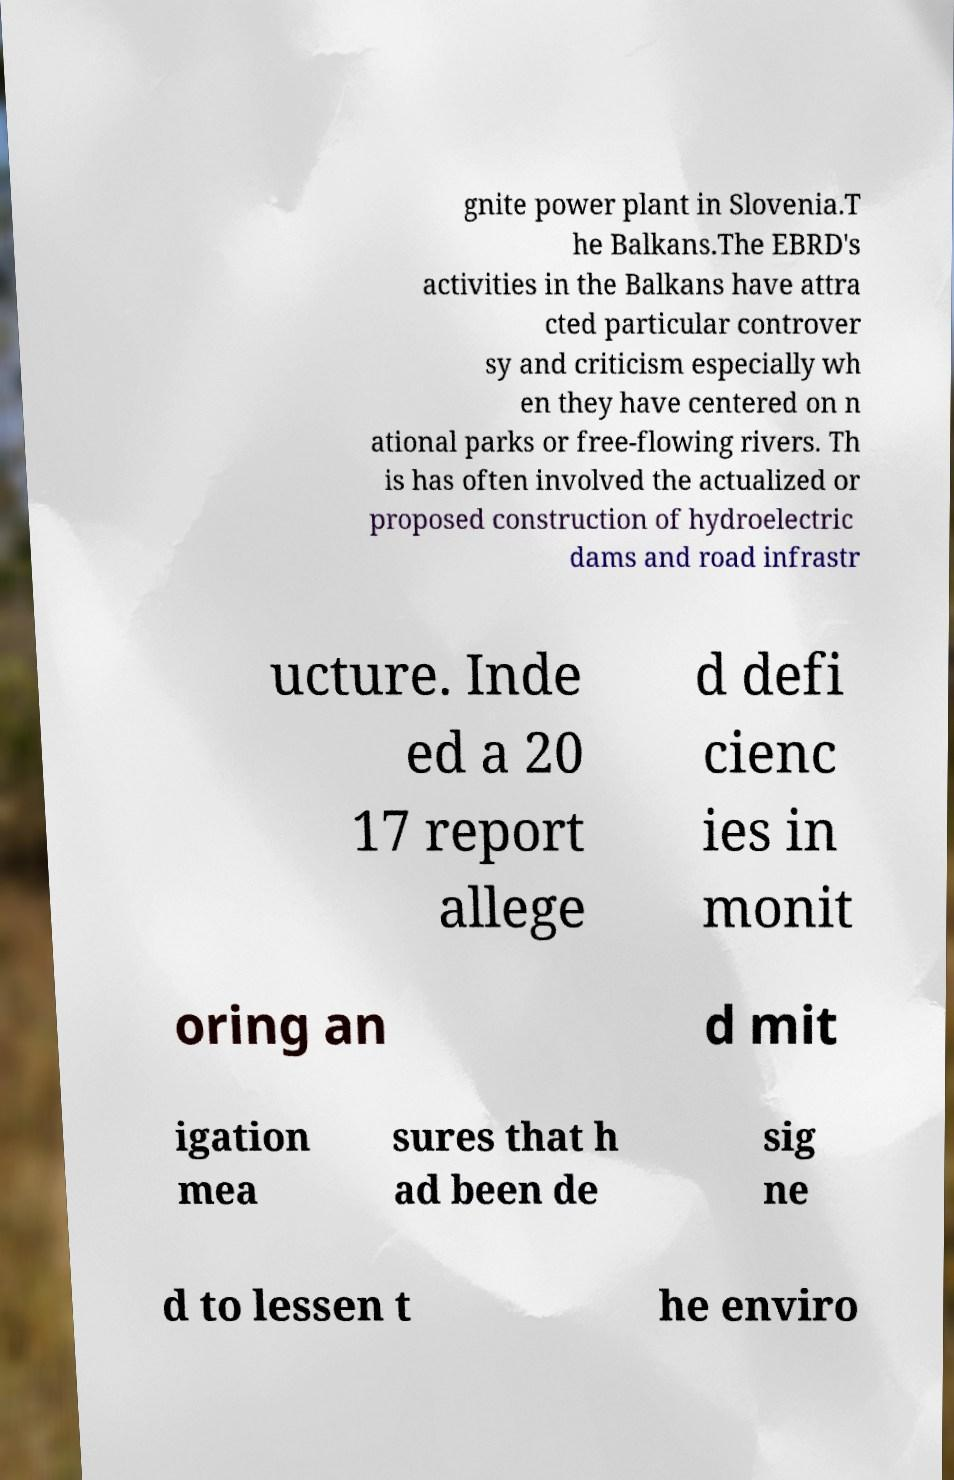Could you extract and type out the text from this image? gnite power plant in Slovenia.T he Balkans.The EBRD's activities in the Balkans have attra cted particular controver sy and criticism especially wh en they have centered on n ational parks or free-flowing rivers. Th is has often involved the actualized or proposed construction of hydroelectric dams and road infrastr ucture. Inde ed a 20 17 report allege d defi cienc ies in monit oring an d mit igation mea sures that h ad been de sig ne d to lessen t he enviro 